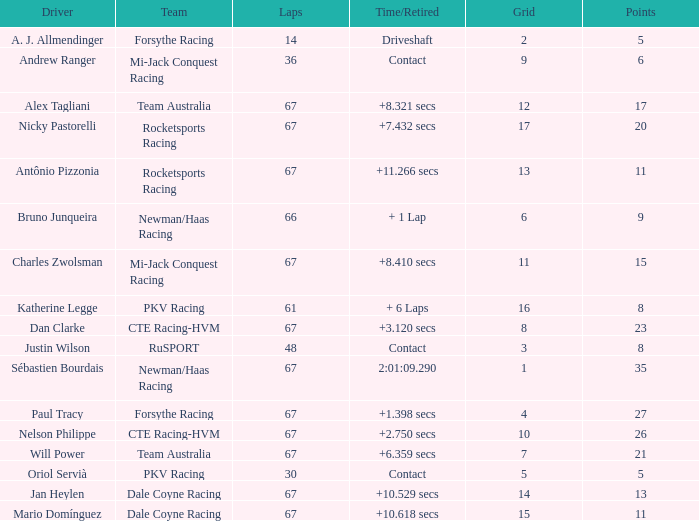What was time/retired with less than 67 laps and 6 points? Contact. 